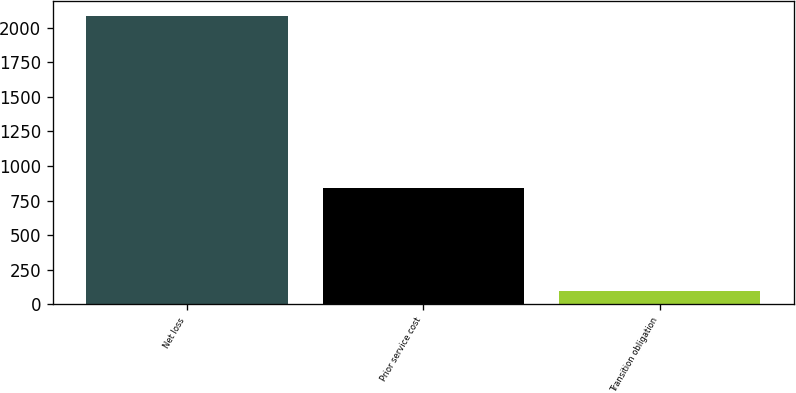Convert chart. <chart><loc_0><loc_0><loc_500><loc_500><bar_chart><fcel>Net loss<fcel>Prior service cost<fcel>Transition obligation<nl><fcel>2088<fcel>841<fcel>94<nl></chart> 